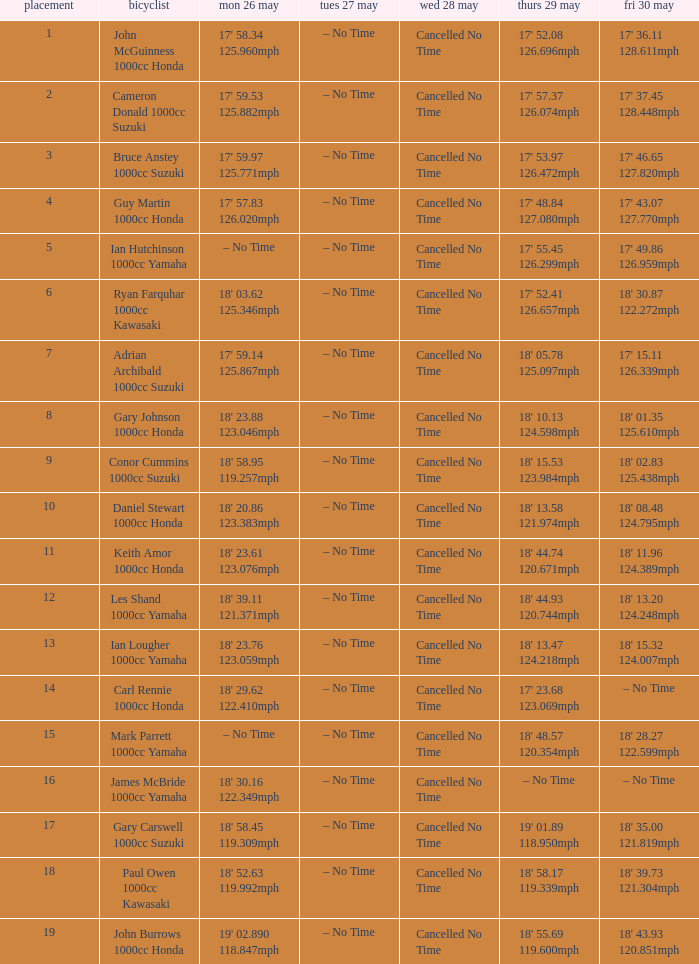What is the numbr for fri may 30 and mon may 26 is 19' 02.890 118.847mph? 18' 43.93 120.851mph. 